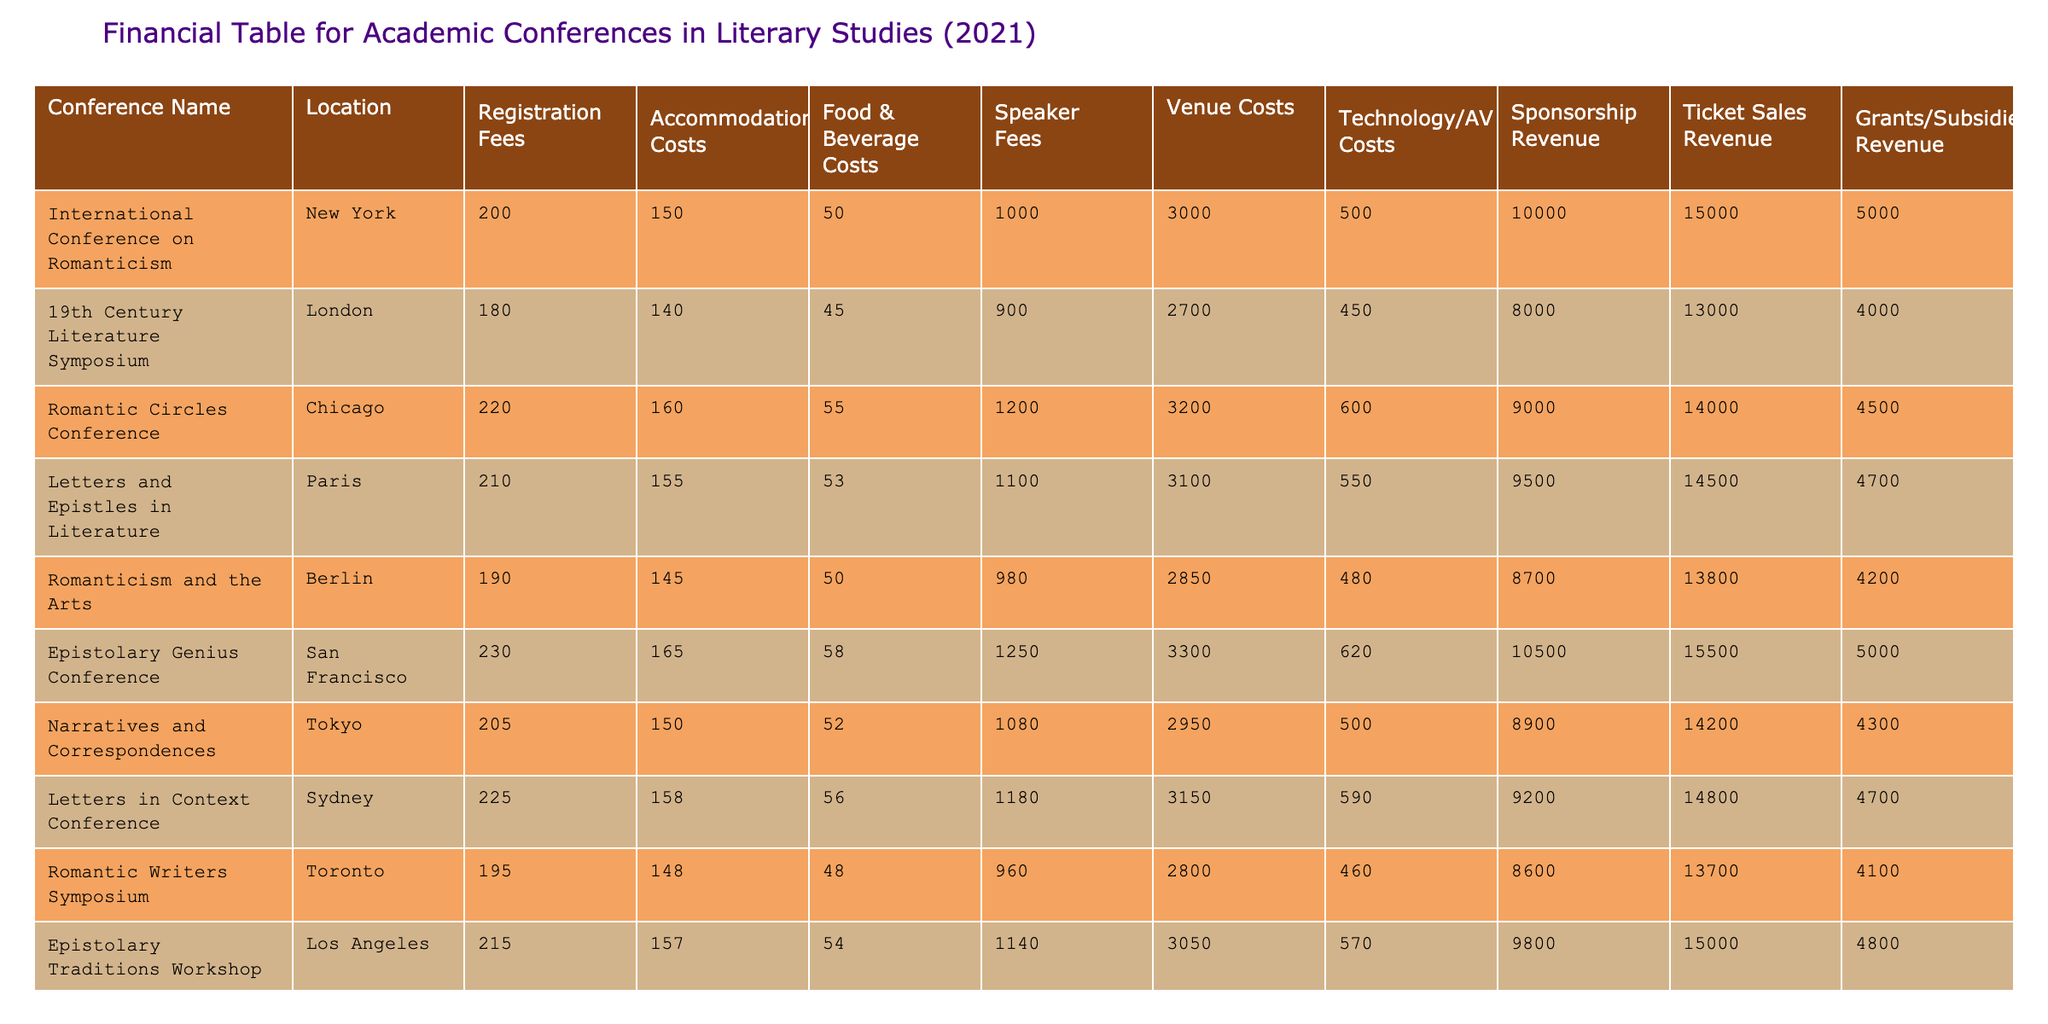What is the highest registration fee among the conferences? By looking at the "Registration Fees" column, we can identify the maximum value. The highest registration fee is 230, associated with the Epistolary Genius Conference in San Francisco.
Answer: 230 What is the total accommodation cost for all conferences combined? To find the total accommodation cost, sum the values in the "Accommodation Costs" column: 150 + 140 + 160 + 155 + 145 + 165 + 150 + 158 + 148 + 157 = 1518.
Answer: 1518 Is there a conference where speaker fees are higher than 1000? Checking the "Speaker Fees" column, we see that multiple conferences have speaker fees over 1000. For example, the Epistolary Genius Conference has a speaker fee of 1250, confirming that it is true.
Answer: Yes What is the average technology/AV cost across all the conferences? To calculate the average, sum the "Technology/AV Costs": 500 + 450 + 600 + 550 + 480 + 620 + 500 + 590 + 460 + 570 = 5050. There are 10 conferences, so the average is 5050/10 = 505.
Answer: 505 Which conference had the lowest total costs? To find the conference with the lowest total costs, we calculate total costs as the sum of Registration Fees, Accommodation Costs, Food & Beverage Costs, Speaker Fees, Venue Costs, and Technology/AV Costs. Then, we compare these totals for each conference. The totals for each are: 200+150+50+1000+3000+500=3900 for the International Conference on Romanticism, and similar calculations for the others show that the Romantic Writers Symposium has the lowest total costs of 4100.
Answer: Romantic Writers Symposium What is the total revenue generated from sponsorships from all conferences? To find the total sponsorship revenue, sum the amounts in the "Sponsorship Revenue" column: 10000 + 8000 + 9000 + 9500 + 8700 + 10500 + 8900 + 9200 + 8600 + 9800 = 90000.
Answer: 90000 Are food and beverage costs greater than 50 in all conferences? We can check the "Food & Beverage Costs" column. By examining each value, we see that all values are greater than 50, meaning the statement is true.
Answer: Yes What is the difference in ticket sales revenue between the highest and lowest conference? First, we look at the "Ticket Sales Revenue" for each conference. The highest is 15500 (Epistolary Genius Conference) and the lowest is 13000 (19th Century Literature Symposium). Subtracting gives us 15500 - 13000 = 2500.
Answer: 2500 